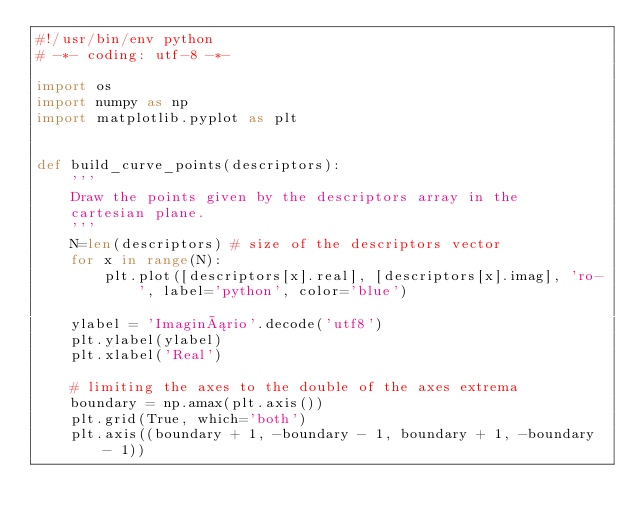Convert code to text. <code><loc_0><loc_0><loc_500><loc_500><_Python_>#!/usr/bin/env python
# -*- coding: utf-8 -*-

import os
import numpy as np
import matplotlib.pyplot as plt


def build_curve_points(descriptors):
    '''
    Draw the points given by the descriptors array in the
    cartesian plane.
    '''
    N=len(descriptors) # size of the descriptors vector
    for x in range(N):
        plt.plot([descriptors[x].real], [descriptors[x].imag], 'ro-', label='python', color='blue')
        
    ylabel = 'Imaginário'.decode('utf8')
    plt.ylabel(ylabel)
    plt.xlabel('Real')

    # limiting the axes to the double of the axes extrema
    boundary = np.amax(plt.axis())
    plt.grid(True, which='both')
    plt.axis((boundary + 1, -boundary - 1, boundary + 1, -boundary - 1))
    </code> 